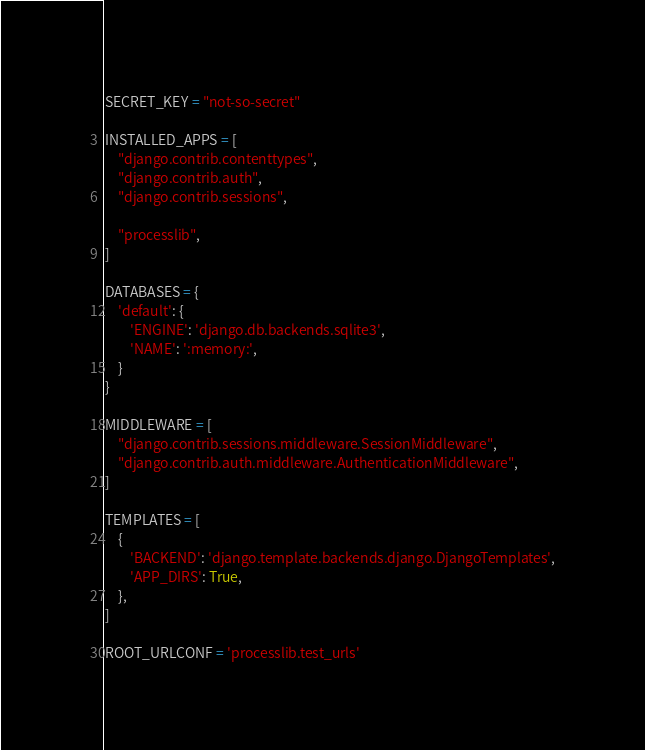Convert code to text. <code><loc_0><loc_0><loc_500><loc_500><_Python_>SECRET_KEY = "not-so-secret"

INSTALLED_APPS = [
    "django.contrib.contenttypes",
    "django.contrib.auth",
    "django.contrib.sessions",

    "processlib",
]

DATABASES = {
    'default': {
        'ENGINE': 'django.db.backends.sqlite3',
        'NAME': ':memory:',
    }
}

MIDDLEWARE = [
    "django.contrib.sessions.middleware.SessionMiddleware",
    "django.contrib.auth.middleware.AuthenticationMiddleware",
]

TEMPLATES = [
    {
        'BACKEND': 'django.template.backends.django.DjangoTemplates',
        'APP_DIRS': True,
    },
]

ROOT_URLCONF = 'processlib.test_urls'
</code> 